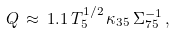<formula> <loc_0><loc_0><loc_500><loc_500>Q \, \approx \, 1 . 1 \, T _ { 5 } ^ { 1 / 2 } \, \kappa _ { 3 5 } \, \Sigma _ { 7 5 } ^ { - 1 } \, ,</formula> 